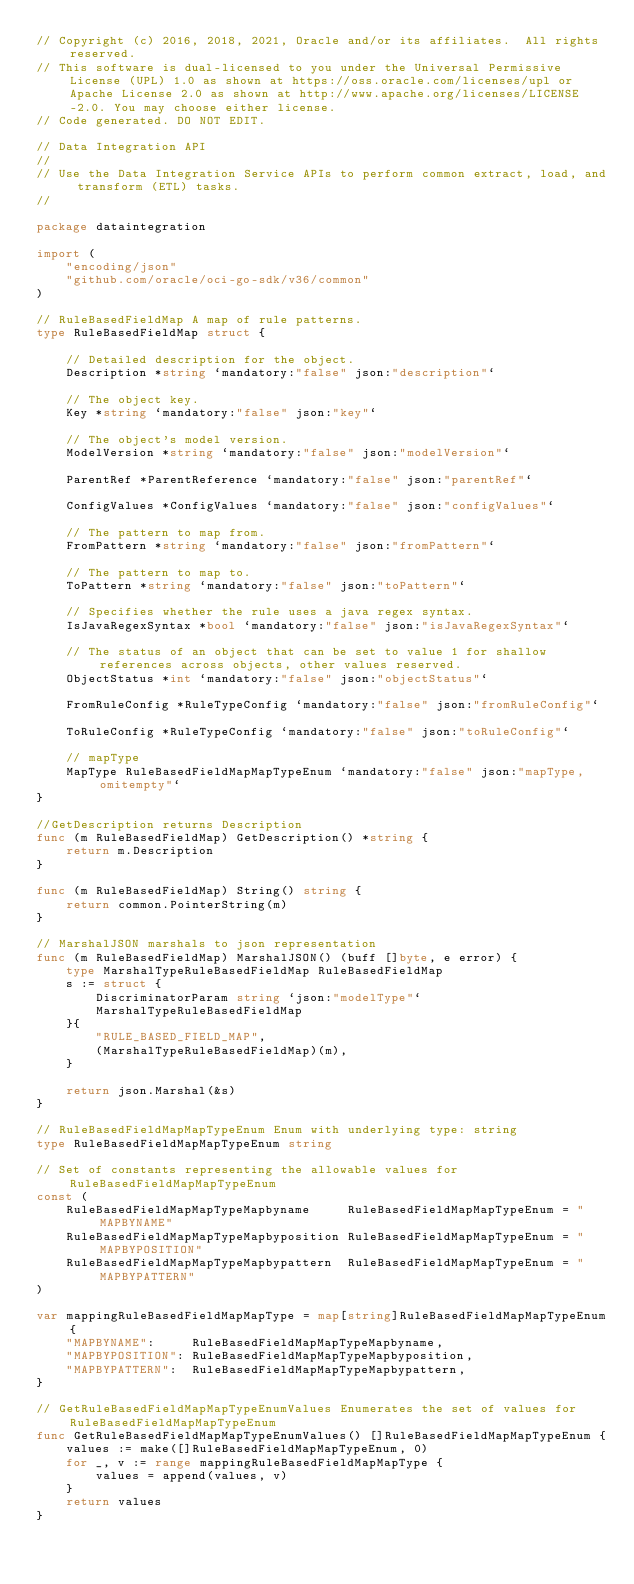Convert code to text. <code><loc_0><loc_0><loc_500><loc_500><_Go_>// Copyright (c) 2016, 2018, 2021, Oracle and/or its affiliates.  All rights reserved.
// This software is dual-licensed to you under the Universal Permissive License (UPL) 1.0 as shown at https://oss.oracle.com/licenses/upl or Apache License 2.0 as shown at http://www.apache.org/licenses/LICENSE-2.0. You may choose either license.
// Code generated. DO NOT EDIT.

// Data Integration API
//
// Use the Data Integration Service APIs to perform common extract, load, and transform (ETL) tasks.
//

package dataintegration

import (
	"encoding/json"
	"github.com/oracle/oci-go-sdk/v36/common"
)

// RuleBasedFieldMap A map of rule patterns.
type RuleBasedFieldMap struct {

	// Detailed description for the object.
	Description *string `mandatory:"false" json:"description"`

	// The object key.
	Key *string `mandatory:"false" json:"key"`

	// The object's model version.
	ModelVersion *string `mandatory:"false" json:"modelVersion"`

	ParentRef *ParentReference `mandatory:"false" json:"parentRef"`

	ConfigValues *ConfigValues `mandatory:"false" json:"configValues"`

	// The pattern to map from.
	FromPattern *string `mandatory:"false" json:"fromPattern"`

	// The pattern to map to.
	ToPattern *string `mandatory:"false" json:"toPattern"`

	// Specifies whether the rule uses a java regex syntax.
	IsJavaRegexSyntax *bool `mandatory:"false" json:"isJavaRegexSyntax"`

	// The status of an object that can be set to value 1 for shallow references across objects, other values reserved.
	ObjectStatus *int `mandatory:"false" json:"objectStatus"`

	FromRuleConfig *RuleTypeConfig `mandatory:"false" json:"fromRuleConfig"`

	ToRuleConfig *RuleTypeConfig `mandatory:"false" json:"toRuleConfig"`

	// mapType
	MapType RuleBasedFieldMapMapTypeEnum `mandatory:"false" json:"mapType,omitempty"`
}

//GetDescription returns Description
func (m RuleBasedFieldMap) GetDescription() *string {
	return m.Description
}

func (m RuleBasedFieldMap) String() string {
	return common.PointerString(m)
}

// MarshalJSON marshals to json representation
func (m RuleBasedFieldMap) MarshalJSON() (buff []byte, e error) {
	type MarshalTypeRuleBasedFieldMap RuleBasedFieldMap
	s := struct {
		DiscriminatorParam string `json:"modelType"`
		MarshalTypeRuleBasedFieldMap
	}{
		"RULE_BASED_FIELD_MAP",
		(MarshalTypeRuleBasedFieldMap)(m),
	}

	return json.Marshal(&s)
}

// RuleBasedFieldMapMapTypeEnum Enum with underlying type: string
type RuleBasedFieldMapMapTypeEnum string

// Set of constants representing the allowable values for RuleBasedFieldMapMapTypeEnum
const (
	RuleBasedFieldMapMapTypeMapbyname     RuleBasedFieldMapMapTypeEnum = "MAPBYNAME"
	RuleBasedFieldMapMapTypeMapbyposition RuleBasedFieldMapMapTypeEnum = "MAPBYPOSITION"
	RuleBasedFieldMapMapTypeMapbypattern  RuleBasedFieldMapMapTypeEnum = "MAPBYPATTERN"
)

var mappingRuleBasedFieldMapMapType = map[string]RuleBasedFieldMapMapTypeEnum{
	"MAPBYNAME":     RuleBasedFieldMapMapTypeMapbyname,
	"MAPBYPOSITION": RuleBasedFieldMapMapTypeMapbyposition,
	"MAPBYPATTERN":  RuleBasedFieldMapMapTypeMapbypattern,
}

// GetRuleBasedFieldMapMapTypeEnumValues Enumerates the set of values for RuleBasedFieldMapMapTypeEnum
func GetRuleBasedFieldMapMapTypeEnumValues() []RuleBasedFieldMapMapTypeEnum {
	values := make([]RuleBasedFieldMapMapTypeEnum, 0)
	for _, v := range mappingRuleBasedFieldMapMapType {
		values = append(values, v)
	}
	return values
}
</code> 